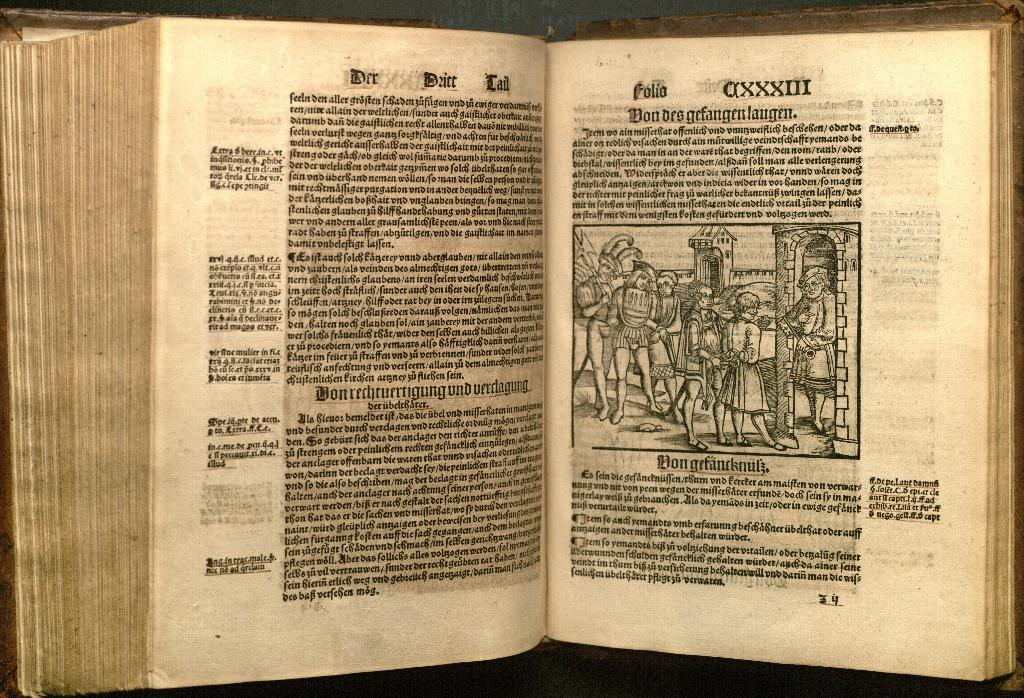<image>
Render a clear and concise summary of the photo. a page that says 'folio don desgefangenlaugen' on it 